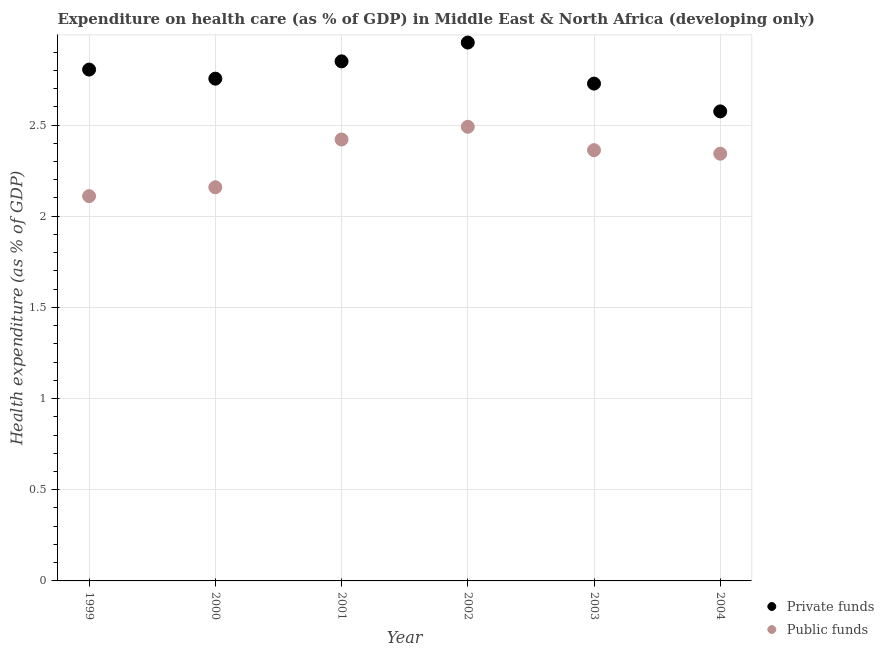How many different coloured dotlines are there?
Provide a short and direct response. 2. What is the amount of public funds spent in healthcare in 2003?
Your answer should be very brief. 2.36. Across all years, what is the maximum amount of private funds spent in healthcare?
Ensure brevity in your answer.  2.95. Across all years, what is the minimum amount of private funds spent in healthcare?
Give a very brief answer. 2.57. What is the total amount of private funds spent in healthcare in the graph?
Provide a short and direct response. 16.66. What is the difference between the amount of private funds spent in healthcare in 2002 and that in 2003?
Offer a terse response. 0.23. What is the difference between the amount of public funds spent in healthcare in 1999 and the amount of private funds spent in healthcare in 2000?
Your response must be concise. -0.64. What is the average amount of private funds spent in healthcare per year?
Your response must be concise. 2.78. In the year 2000, what is the difference between the amount of public funds spent in healthcare and amount of private funds spent in healthcare?
Provide a short and direct response. -0.6. What is the ratio of the amount of public funds spent in healthcare in 1999 to that in 2004?
Ensure brevity in your answer.  0.9. Is the amount of private funds spent in healthcare in 2003 less than that in 2004?
Give a very brief answer. No. Is the difference between the amount of private funds spent in healthcare in 2002 and 2003 greater than the difference between the amount of public funds spent in healthcare in 2002 and 2003?
Provide a short and direct response. Yes. What is the difference between the highest and the second highest amount of public funds spent in healthcare?
Offer a very short reply. 0.07. What is the difference between the highest and the lowest amount of private funds spent in healthcare?
Offer a terse response. 0.38. Does the amount of private funds spent in healthcare monotonically increase over the years?
Give a very brief answer. No. Are the values on the major ticks of Y-axis written in scientific E-notation?
Ensure brevity in your answer.  No. Does the graph contain any zero values?
Your response must be concise. No. Where does the legend appear in the graph?
Offer a terse response. Bottom right. What is the title of the graph?
Offer a terse response. Expenditure on health care (as % of GDP) in Middle East & North Africa (developing only). Does "Current education expenditure" appear as one of the legend labels in the graph?
Make the answer very short. No. What is the label or title of the Y-axis?
Your answer should be very brief. Health expenditure (as % of GDP). What is the Health expenditure (as % of GDP) of Private funds in 1999?
Give a very brief answer. 2.8. What is the Health expenditure (as % of GDP) in Public funds in 1999?
Keep it short and to the point. 2.11. What is the Health expenditure (as % of GDP) of Private funds in 2000?
Provide a succinct answer. 2.75. What is the Health expenditure (as % of GDP) of Public funds in 2000?
Offer a terse response. 2.16. What is the Health expenditure (as % of GDP) of Private funds in 2001?
Offer a terse response. 2.85. What is the Health expenditure (as % of GDP) in Public funds in 2001?
Your answer should be compact. 2.42. What is the Health expenditure (as % of GDP) of Private funds in 2002?
Your answer should be compact. 2.95. What is the Health expenditure (as % of GDP) of Public funds in 2002?
Offer a terse response. 2.49. What is the Health expenditure (as % of GDP) in Private funds in 2003?
Ensure brevity in your answer.  2.73. What is the Health expenditure (as % of GDP) of Public funds in 2003?
Provide a succinct answer. 2.36. What is the Health expenditure (as % of GDP) in Private funds in 2004?
Keep it short and to the point. 2.57. What is the Health expenditure (as % of GDP) of Public funds in 2004?
Make the answer very short. 2.34. Across all years, what is the maximum Health expenditure (as % of GDP) in Private funds?
Your response must be concise. 2.95. Across all years, what is the maximum Health expenditure (as % of GDP) of Public funds?
Offer a very short reply. 2.49. Across all years, what is the minimum Health expenditure (as % of GDP) of Private funds?
Keep it short and to the point. 2.57. Across all years, what is the minimum Health expenditure (as % of GDP) of Public funds?
Ensure brevity in your answer.  2.11. What is the total Health expenditure (as % of GDP) of Private funds in the graph?
Make the answer very short. 16.66. What is the total Health expenditure (as % of GDP) in Public funds in the graph?
Provide a short and direct response. 13.89. What is the difference between the Health expenditure (as % of GDP) of Private funds in 1999 and that in 2000?
Offer a very short reply. 0.05. What is the difference between the Health expenditure (as % of GDP) of Public funds in 1999 and that in 2000?
Make the answer very short. -0.05. What is the difference between the Health expenditure (as % of GDP) of Private funds in 1999 and that in 2001?
Your answer should be very brief. -0.05. What is the difference between the Health expenditure (as % of GDP) in Public funds in 1999 and that in 2001?
Provide a short and direct response. -0.31. What is the difference between the Health expenditure (as % of GDP) of Private funds in 1999 and that in 2002?
Make the answer very short. -0.15. What is the difference between the Health expenditure (as % of GDP) in Public funds in 1999 and that in 2002?
Your answer should be very brief. -0.38. What is the difference between the Health expenditure (as % of GDP) in Private funds in 1999 and that in 2003?
Make the answer very short. 0.08. What is the difference between the Health expenditure (as % of GDP) of Public funds in 1999 and that in 2003?
Your answer should be very brief. -0.25. What is the difference between the Health expenditure (as % of GDP) of Private funds in 1999 and that in 2004?
Provide a short and direct response. 0.23. What is the difference between the Health expenditure (as % of GDP) in Public funds in 1999 and that in 2004?
Provide a succinct answer. -0.23. What is the difference between the Health expenditure (as % of GDP) of Private funds in 2000 and that in 2001?
Provide a succinct answer. -0.1. What is the difference between the Health expenditure (as % of GDP) of Public funds in 2000 and that in 2001?
Your answer should be very brief. -0.26. What is the difference between the Health expenditure (as % of GDP) of Private funds in 2000 and that in 2002?
Give a very brief answer. -0.2. What is the difference between the Health expenditure (as % of GDP) of Public funds in 2000 and that in 2002?
Give a very brief answer. -0.33. What is the difference between the Health expenditure (as % of GDP) of Private funds in 2000 and that in 2003?
Provide a succinct answer. 0.03. What is the difference between the Health expenditure (as % of GDP) of Public funds in 2000 and that in 2003?
Give a very brief answer. -0.2. What is the difference between the Health expenditure (as % of GDP) in Private funds in 2000 and that in 2004?
Keep it short and to the point. 0.18. What is the difference between the Health expenditure (as % of GDP) of Public funds in 2000 and that in 2004?
Your answer should be compact. -0.18. What is the difference between the Health expenditure (as % of GDP) in Private funds in 2001 and that in 2002?
Make the answer very short. -0.1. What is the difference between the Health expenditure (as % of GDP) of Public funds in 2001 and that in 2002?
Your response must be concise. -0.07. What is the difference between the Health expenditure (as % of GDP) in Private funds in 2001 and that in 2003?
Your answer should be compact. 0.12. What is the difference between the Health expenditure (as % of GDP) of Public funds in 2001 and that in 2003?
Make the answer very short. 0.06. What is the difference between the Health expenditure (as % of GDP) in Private funds in 2001 and that in 2004?
Give a very brief answer. 0.27. What is the difference between the Health expenditure (as % of GDP) of Public funds in 2001 and that in 2004?
Provide a short and direct response. 0.08. What is the difference between the Health expenditure (as % of GDP) of Private funds in 2002 and that in 2003?
Your answer should be very brief. 0.23. What is the difference between the Health expenditure (as % of GDP) of Public funds in 2002 and that in 2003?
Your response must be concise. 0.13. What is the difference between the Health expenditure (as % of GDP) of Private funds in 2002 and that in 2004?
Your answer should be very brief. 0.38. What is the difference between the Health expenditure (as % of GDP) of Public funds in 2002 and that in 2004?
Make the answer very short. 0.15. What is the difference between the Health expenditure (as % of GDP) in Private funds in 2003 and that in 2004?
Your answer should be very brief. 0.15. What is the difference between the Health expenditure (as % of GDP) in Public funds in 2003 and that in 2004?
Your response must be concise. 0.02. What is the difference between the Health expenditure (as % of GDP) of Private funds in 1999 and the Health expenditure (as % of GDP) of Public funds in 2000?
Make the answer very short. 0.65. What is the difference between the Health expenditure (as % of GDP) in Private funds in 1999 and the Health expenditure (as % of GDP) in Public funds in 2001?
Keep it short and to the point. 0.38. What is the difference between the Health expenditure (as % of GDP) in Private funds in 1999 and the Health expenditure (as % of GDP) in Public funds in 2002?
Your answer should be compact. 0.31. What is the difference between the Health expenditure (as % of GDP) of Private funds in 1999 and the Health expenditure (as % of GDP) of Public funds in 2003?
Make the answer very short. 0.44. What is the difference between the Health expenditure (as % of GDP) in Private funds in 1999 and the Health expenditure (as % of GDP) in Public funds in 2004?
Give a very brief answer. 0.46. What is the difference between the Health expenditure (as % of GDP) of Private funds in 2000 and the Health expenditure (as % of GDP) of Public funds in 2001?
Offer a terse response. 0.33. What is the difference between the Health expenditure (as % of GDP) of Private funds in 2000 and the Health expenditure (as % of GDP) of Public funds in 2002?
Make the answer very short. 0.26. What is the difference between the Health expenditure (as % of GDP) in Private funds in 2000 and the Health expenditure (as % of GDP) in Public funds in 2003?
Keep it short and to the point. 0.39. What is the difference between the Health expenditure (as % of GDP) of Private funds in 2000 and the Health expenditure (as % of GDP) of Public funds in 2004?
Offer a very short reply. 0.41. What is the difference between the Health expenditure (as % of GDP) of Private funds in 2001 and the Health expenditure (as % of GDP) of Public funds in 2002?
Your answer should be compact. 0.36. What is the difference between the Health expenditure (as % of GDP) in Private funds in 2001 and the Health expenditure (as % of GDP) in Public funds in 2003?
Provide a short and direct response. 0.49. What is the difference between the Health expenditure (as % of GDP) in Private funds in 2001 and the Health expenditure (as % of GDP) in Public funds in 2004?
Your answer should be compact. 0.51. What is the difference between the Health expenditure (as % of GDP) in Private funds in 2002 and the Health expenditure (as % of GDP) in Public funds in 2003?
Ensure brevity in your answer.  0.59. What is the difference between the Health expenditure (as % of GDP) of Private funds in 2002 and the Health expenditure (as % of GDP) of Public funds in 2004?
Your answer should be compact. 0.61. What is the difference between the Health expenditure (as % of GDP) of Private funds in 2003 and the Health expenditure (as % of GDP) of Public funds in 2004?
Your answer should be compact. 0.38. What is the average Health expenditure (as % of GDP) in Private funds per year?
Your answer should be compact. 2.78. What is the average Health expenditure (as % of GDP) in Public funds per year?
Make the answer very short. 2.31. In the year 1999, what is the difference between the Health expenditure (as % of GDP) in Private funds and Health expenditure (as % of GDP) in Public funds?
Offer a very short reply. 0.69. In the year 2000, what is the difference between the Health expenditure (as % of GDP) of Private funds and Health expenditure (as % of GDP) of Public funds?
Offer a terse response. 0.6. In the year 2001, what is the difference between the Health expenditure (as % of GDP) of Private funds and Health expenditure (as % of GDP) of Public funds?
Ensure brevity in your answer.  0.43. In the year 2002, what is the difference between the Health expenditure (as % of GDP) in Private funds and Health expenditure (as % of GDP) in Public funds?
Your answer should be compact. 0.46. In the year 2003, what is the difference between the Health expenditure (as % of GDP) in Private funds and Health expenditure (as % of GDP) in Public funds?
Provide a short and direct response. 0.37. In the year 2004, what is the difference between the Health expenditure (as % of GDP) of Private funds and Health expenditure (as % of GDP) of Public funds?
Provide a short and direct response. 0.23. What is the ratio of the Health expenditure (as % of GDP) in Private funds in 1999 to that in 2000?
Provide a succinct answer. 1.02. What is the ratio of the Health expenditure (as % of GDP) in Public funds in 1999 to that in 2000?
Your answer should be compact. 0.98. What is the ratio of the Health expenditure (as % of GDP) of Private funds in 1999 to that in 2001?
Give a very brief answer. 0.98. What is the ratio of the Health expenditure (as % of GDP) of Public funds in 1999 to that in 2001?
Provide a succinct answer. 0.87. What is the ratio of the Health expenditure (as % of GDP) in Private funds in 1999 to that in 2002?
Provide a short and direct response. 0.95. What is the ratio of the Health expenditure (as % of GDP) of Public funds in 1999 to that in 2002?
Your answer should be very brief. 0.85. What is the ratio of the Health expenditure (as % of GDP) of Private funds in 1999 to that in 2003?
Offer a terse response. 1.03. What is the ratio of the Health expenditure (as % of GDP) of Public funds in 1999 to that in 2003?
Offer a terse response. 0.89. What is the ratio of the Health expenditure (as % of GDP) in Private funds in 1999 to that in 2004?
Make the answer very short. 1.09. What is the ratio of the Health expenditure (as % of GDP) of Public funds in 1999 to that in 2004?
Provide a short and direct response. 0.9. What is the ratio of the Health expenditure (as % of GDP) in Private funds in 2000 to that in 2001?
Your answer should be compact. 0.97. What is the ratio of the Health expenditure (as % of GDP) in Public funds in 2000 to that in 2001?
Keep it short and to the point. 0.89. What is the ratio of the Health expenditure (as % of GDP) of Private funds in 2000 to that in 2002?
Make the answer very short. 0.93. What is the ratio of the Health expenditure (as % of GDP) in Public funds in 2000 to that in 2002?
Your answer should be very brief. 0.87. What is the ratio of the Health expenditure (as % of GDP) of Private funds in 2000 to that in 2003?
Offer a terse response. 1.01. What is the ratio of the Health expenditure (as % of GDP) in Public funds in 2000 to that in 2003?
Your answer should be very brief. 0.91. What is the ratio of the Health expenditure (as % of GDP) in Private funds in 2000 to that in 2004?
Provide a succinct answer. 1.07. What is the ratio of the Health expenditure (as % of GDP) of Public funds in 2000 to that in 2004?
Your answer should be compact. 0.92. What is the ratio of the Health expenditure (as % of GDP) of Private funds in 2001 to that in 2002?
Your response must be concise. 0.97. What is the ratio of the Health expenditure (as % of GDP) of Public funds in 2001 to that in 2002?
Your response must be concise. 0.97. What is the ratio of the Health expenditure (as % of GDP) of Private funds in 2001 to that in 2003?
Your response must be concise. 1.04. What is the ratio of the Health expenditure (as % of GDP) in Public funds in 2001 to that in 2003?
Your response must be concise. 1.02. What is the ratio of the Health expenditure (as % of GDP) of Private funds in 2001 to that in 2004?
Make the answer very short. 1.11. What is the ratio of the Health expenditure (as % of GDP) of Public funds in 2001 to that in 2004?
Your answer should be compact. 1.03. What is the ratio of the Health expenditure (as % of GDP) in Private funds in 2002 to that in 2003?
Your response must be concise. 1.08. What is the ratio of the Health expenditure (as % of GDP) of Public funds in 2002 to that in 2003?
Provide a short and direct response. 1.05. What is the ratio of the Health expenditure (as % of GDP) of Private funds in 2002 to that in 2004?
Ensure brevity in your answer.  1.15. What is the ratio of the Health expenditure (as % of GDP) in Public funds in 2002 to that in 2004?
Your answer should be very brief. 1.06. What is the ratio of the Health expenditure (as % of GDP) in Private funds in 2003 to that in 2004?
Give a very brief answer. 1.06. What is the ratio of the Health expenditure (as % of GDP) of Public funds in 2003 to that in 2004?
Offer a terse response. 1.01. What is the difference between the highest and the second highest Health expenditure (as % of GDP) of Private funds?
Make the answer very short. 0.1. What is the difference between the highest and the second highest Health expenditure (as % of GDP) of Public funds?
Ensure brevity in your answer.  0.07. What is the difference between the highest and the lowest Health expenditure (as % of GDP) of Private funds?
Provide a succinct answer. 0.38. What is the difference between the highest and the lowest Health expenditure (as % of GDP) of Public funds?
Provide a short and direct response. 0.38. 